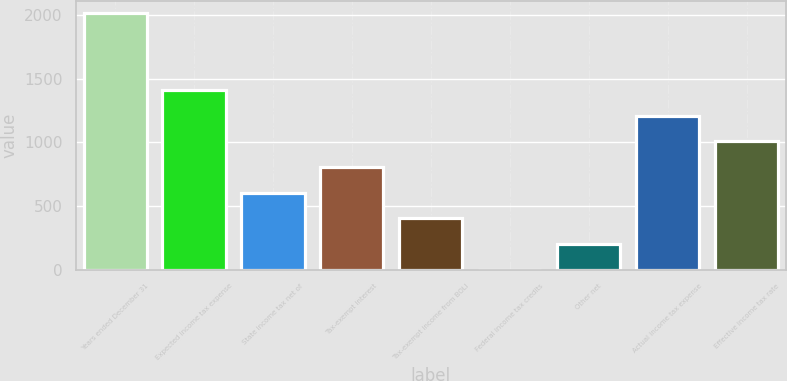Convert chart. <chart><loc_0><loc_0><loc_500><loc_500><bar_chart><fcel>Years ended December 31<fcel>Expected income tax expense<fcel>State income tax net of<fcel>Tax-exempt interest<fcel>Tax-exempt income from BOLI<fcel>Federal income tax credits<fcel>Other net<fcel>Actual income tax expense<fcel>Effective income tax rate<nl><fcel>2014<fcel>1410.04<fcel>604.76<fcel>806.08<fcel>403.44<fcel>0.8<fcel>202.12<fcel>1208.72<fcel>1007.4<nl></chart> 